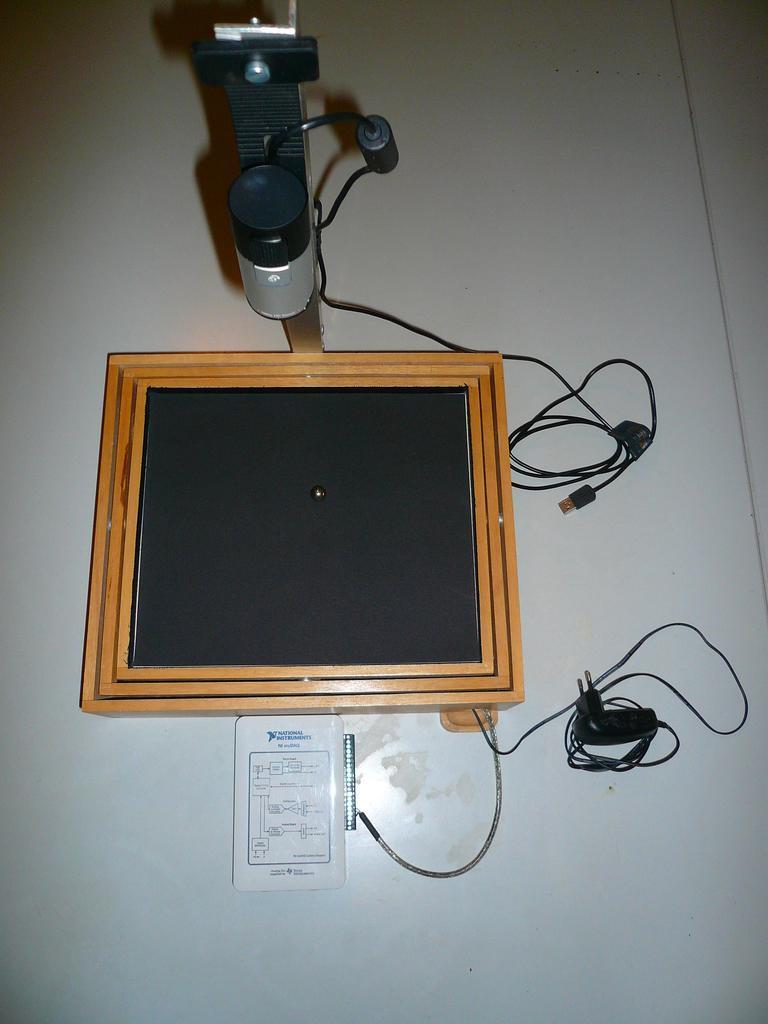In one or two sentences, can you explain what this image depicts? In this image we can see an object which is in black color, here we can see the wires which are placed on the white color surface. 